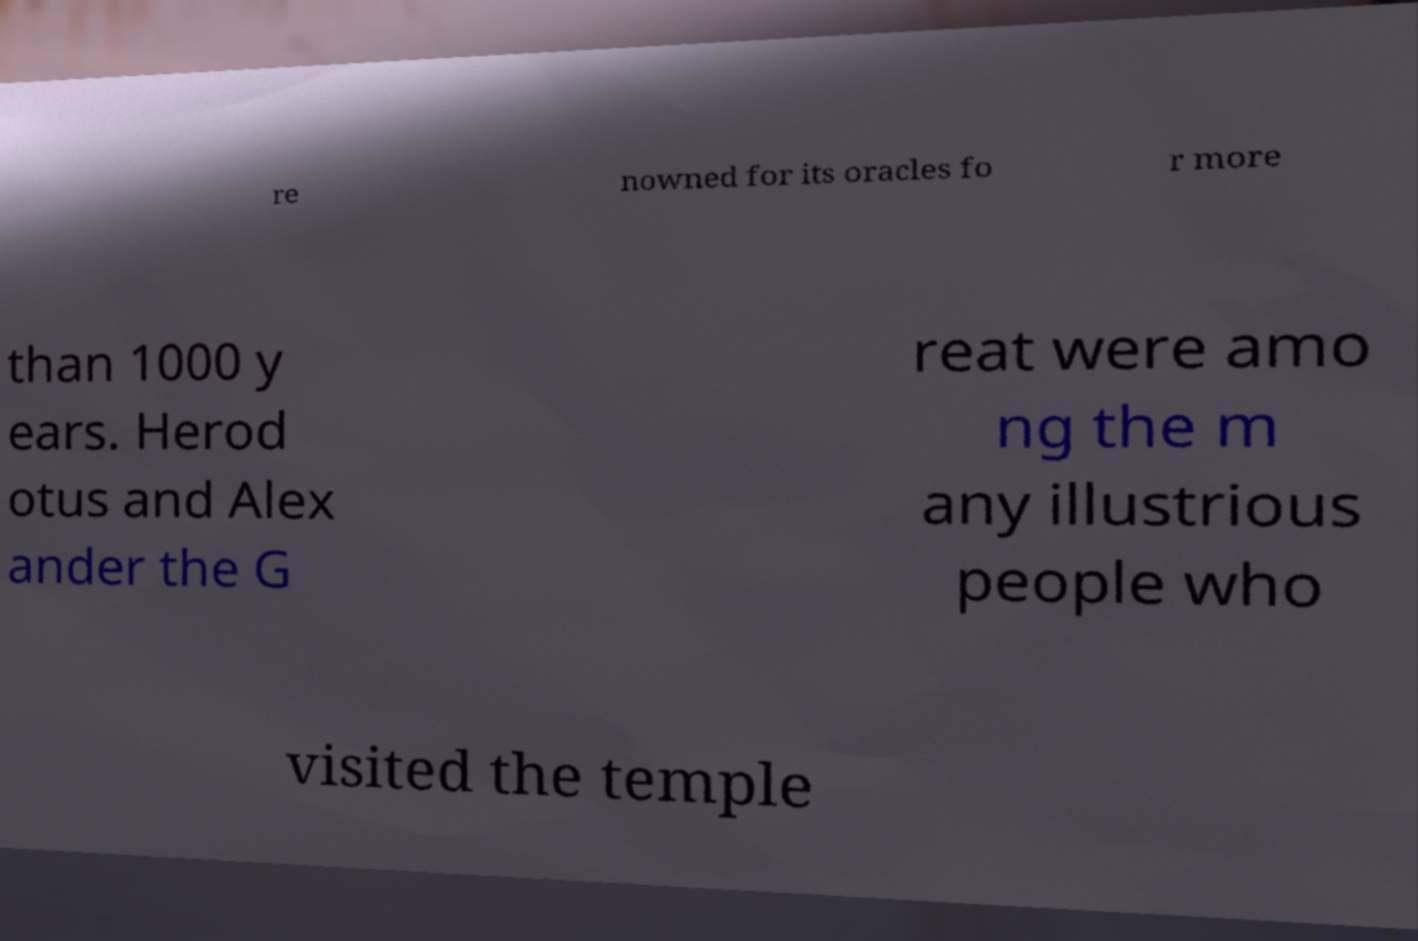For documentation purposes, I need the text within this image transcribed. Could you provide that? re nowned for its oracles fo r more than 1000 y ears. Herod otus and Alex ander the G reat were amo ng the m any illustrious people who visited the temple 